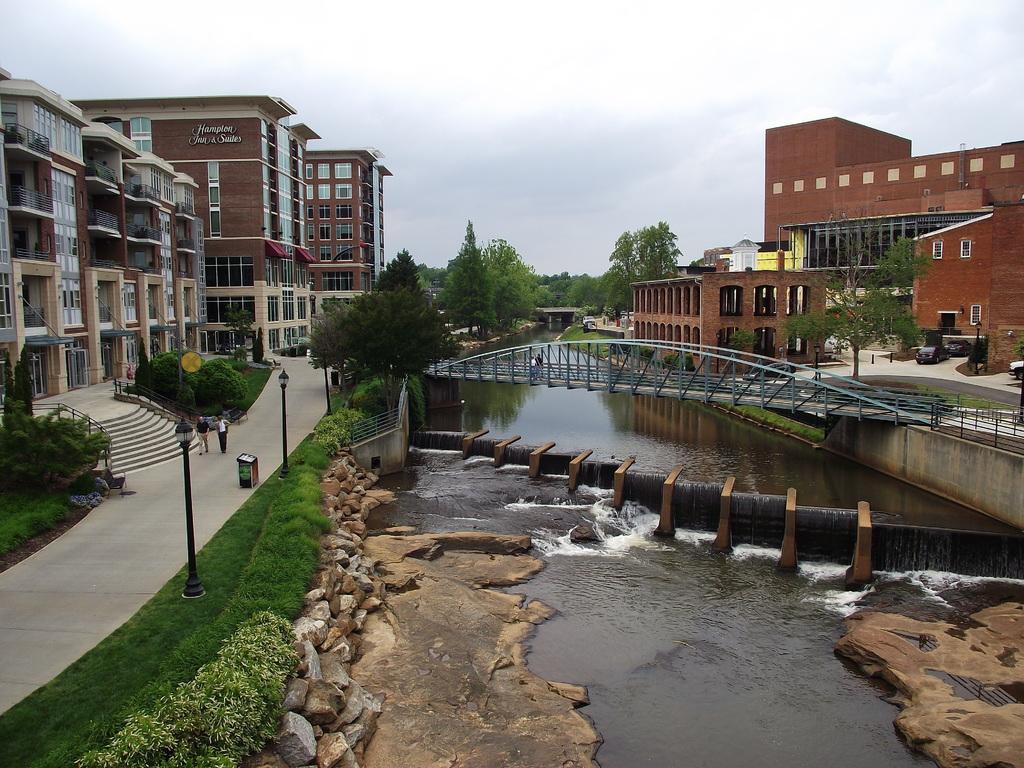Describe this image in one or two sentences. In this image we can see a group of buildings with windows. We can also see a signboard, street poles, a staircase, some people standing on the pathway, a dustbin, some grass, plants, a group of trees, stones and some vehicles parked on the ground. We can also see the water body under a bridge, two persons standing on the bridge, a fence and the sky which looks cloudy. 